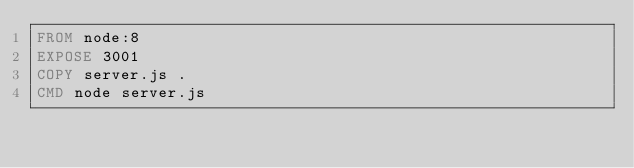<code> <loc_0><loc_0><loc_500><loc_500><_Dockerfile_>FROM node:8
EXPOSE 3001
COPY server.js .
CMD node server.js</code> 